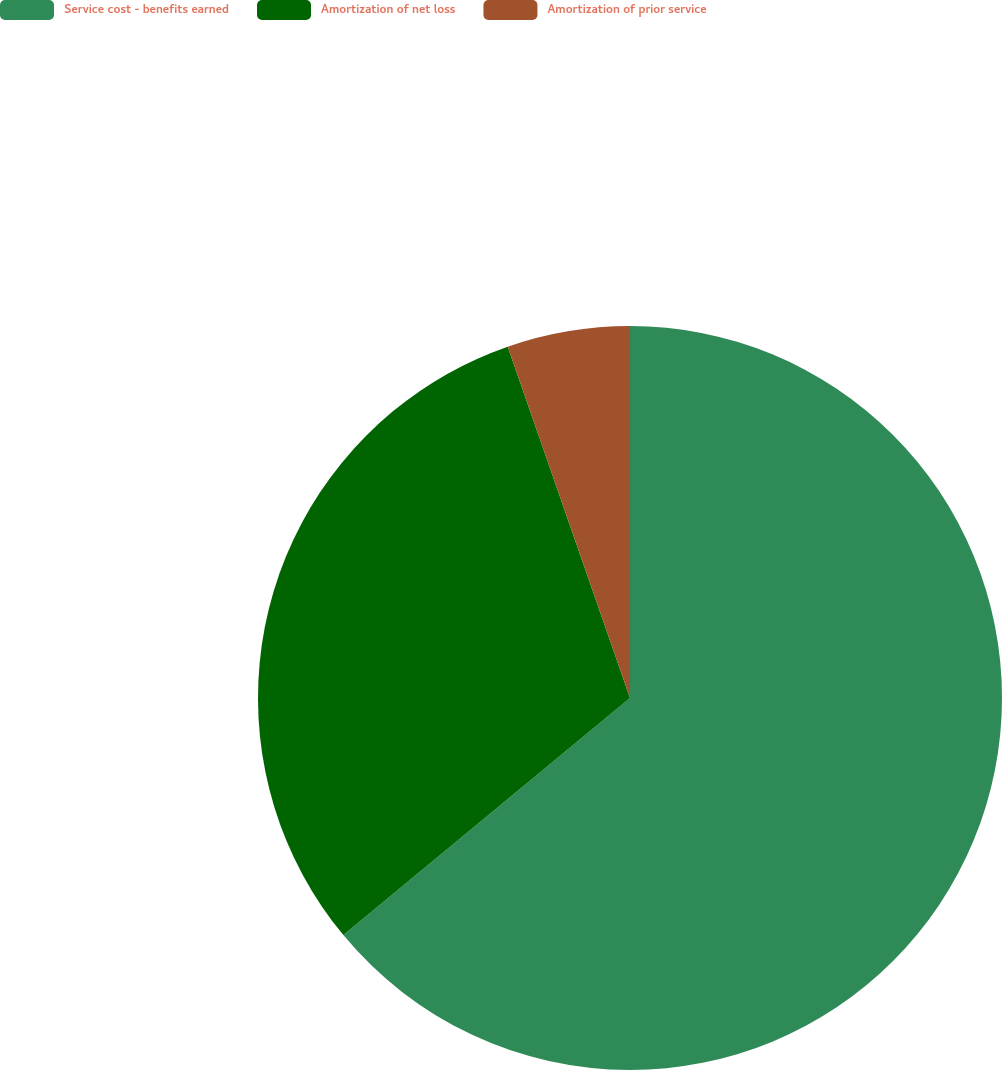Convert chart. <chart><loc_0><loc_0><loc_500><loc_500><pie_chart><fcel>Service cost - benefits earned<fcel>Amortization of net loss<fcel>Amortization of prior service<nl><fcel>64.0%<fcel>30.67%<fcel>5.33%<nl></chart> 